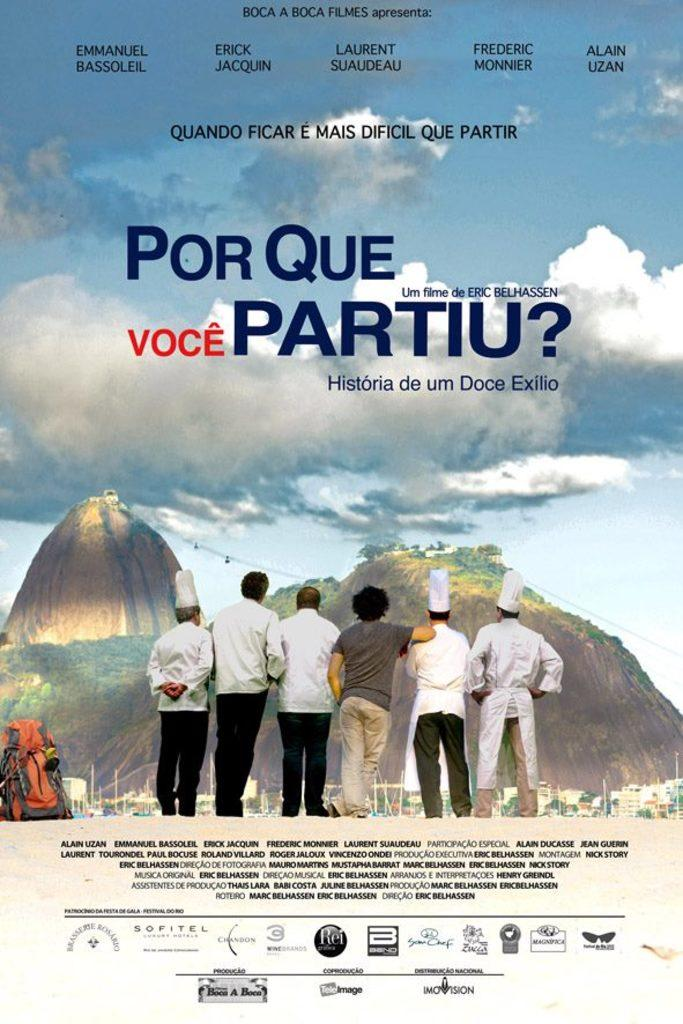<image>
Summarize the visual content of the image. Poster showing a group of people looking at a mountain with the words "Por Que Voce Partiu?" on top. 